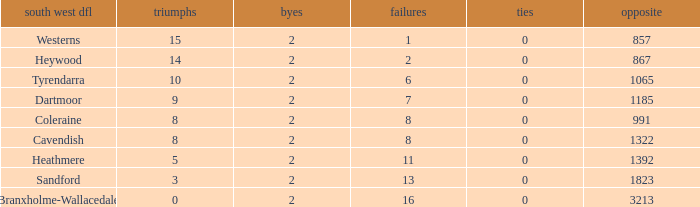Which Losses have a South West DFL of branxholme-wallacedale, and less than 2 Byes? None. 